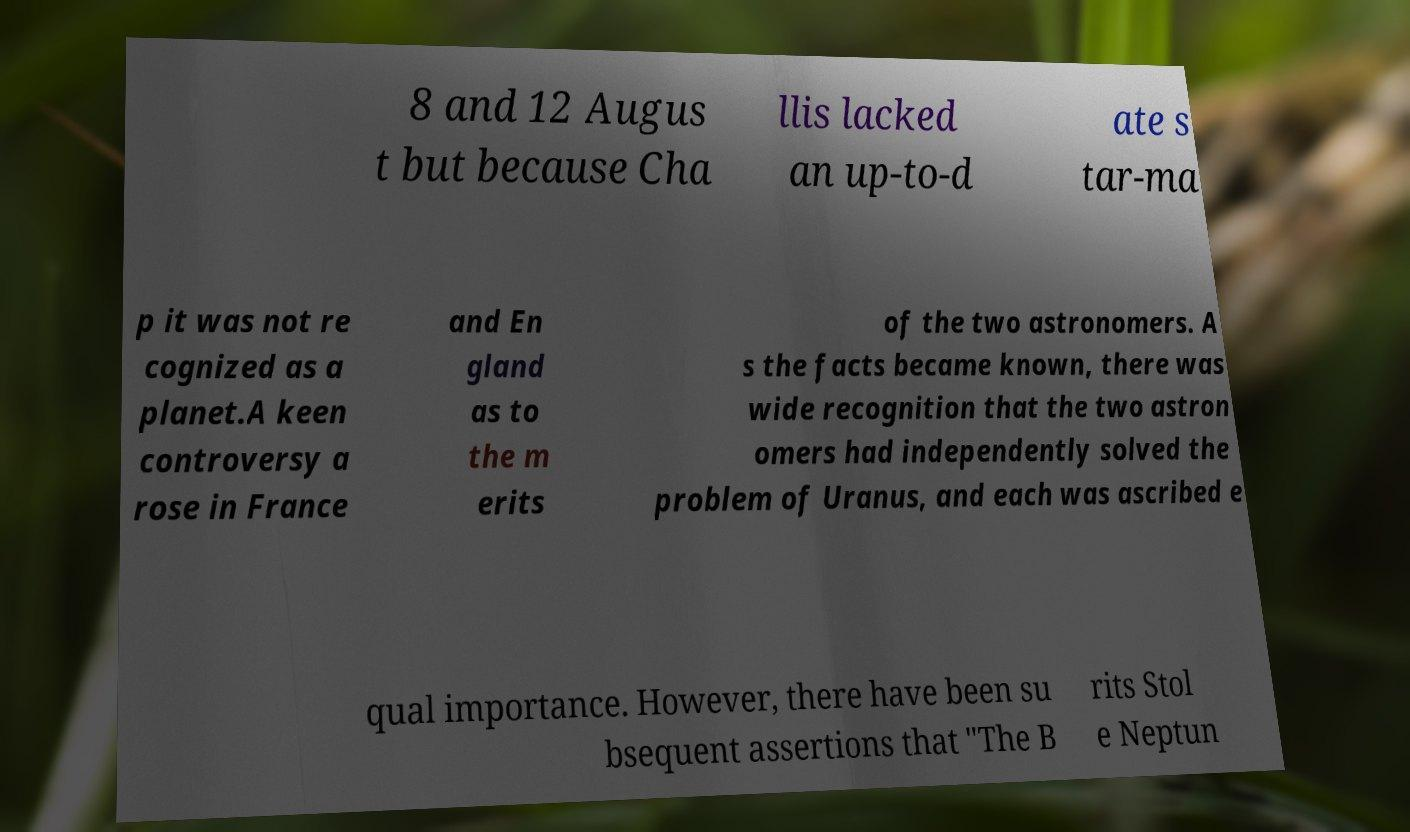Can you accurately transcribe the text from the provided image for me? 8 and 12 Augus t but because Cha llis lacked an up-to-d ate s tar-ma p it was not re cognized as a planet.A keen controversy a rose in France and En gland as to the m erits of the two astronomers. A s the facts became known, there was wide recognition that the two astron omers had independently solved the problem of Uranus, and each was ascribed e qual importance. However, there have been su bsequent assertions that "The B rits Stol e Neptun 